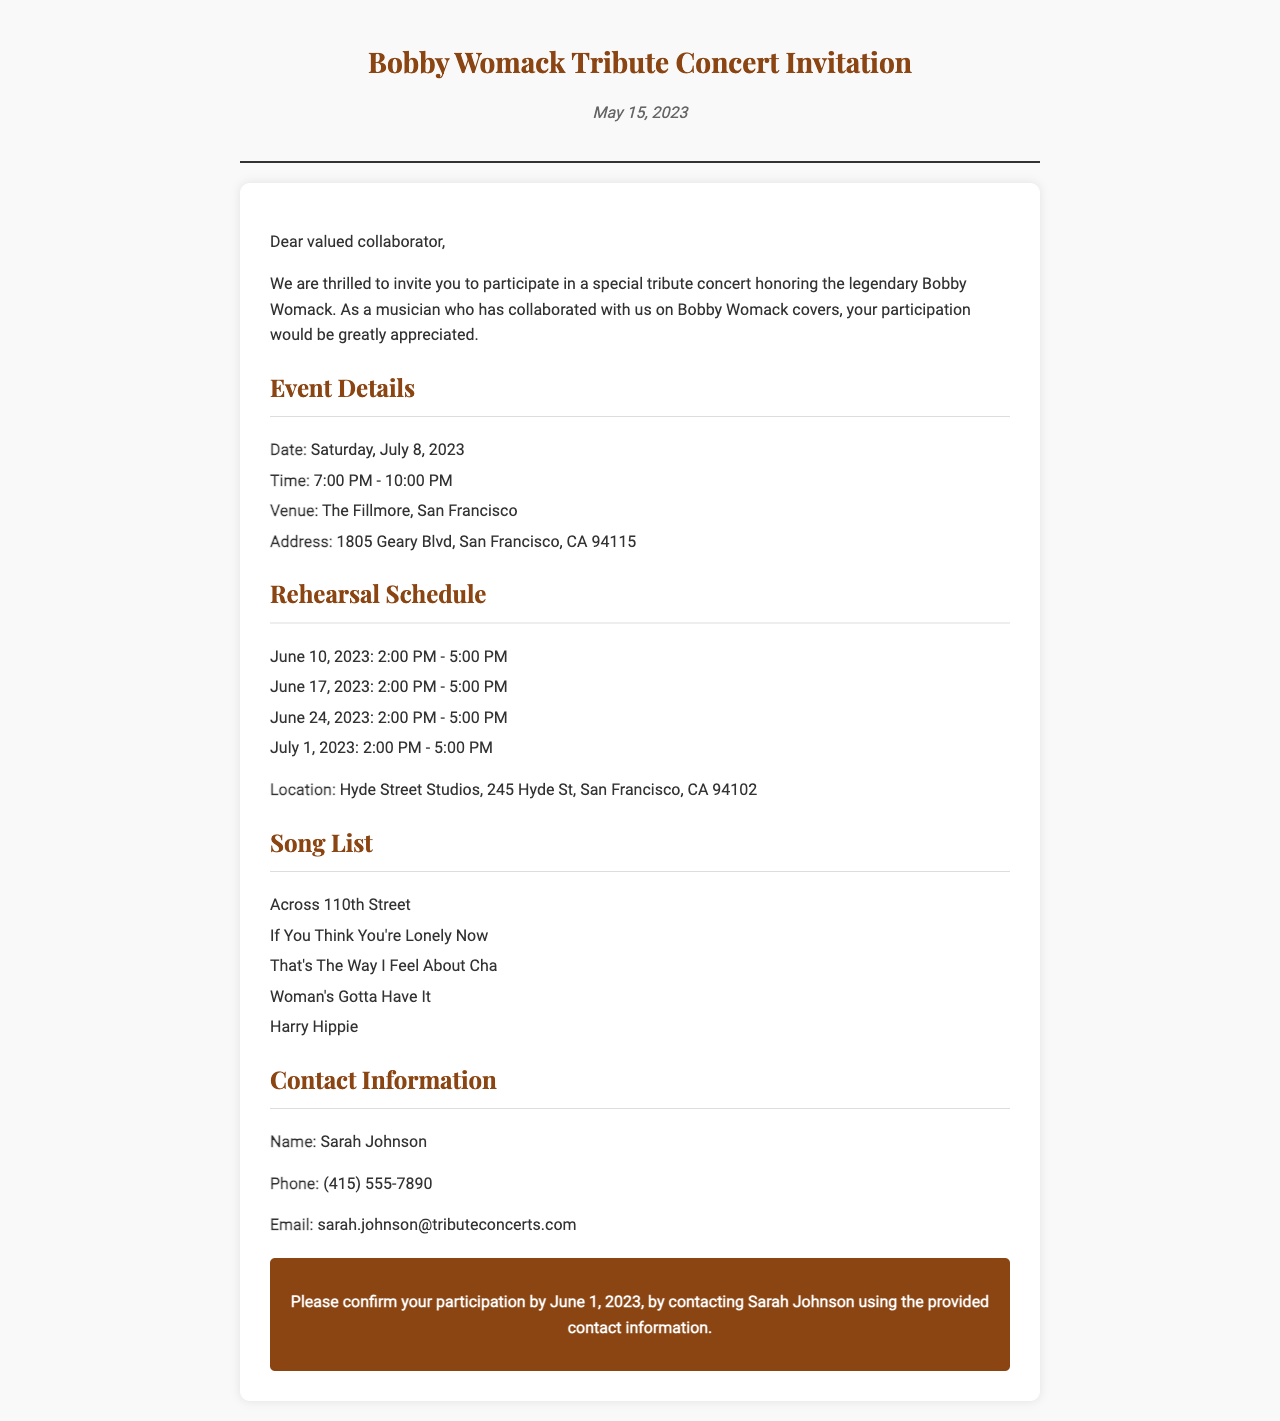What is the date of the concert? The concert is scheduled for July 8, 2023, as stated in the event details.
Answer: July 8, 2023 What is the venue for the tribute concert? The venue listed for the concert is The Fillmore, as mentioned in the event details.
Answer: The Fillmore What time does the concert start? The concert starts at 7:00 PM according to the event details.
Answer: 7:00 PM How many rehearsals are scheduled before the concert? There are four rehearsals listed before the concert, as shown in the rehearsal schedule.
Answer: Four Who should be contacted to confirm participation? Sarah Johnson is the person to contact, as mentioned in the contact information section.
Answer: Sarah Johnson What is the address of the rehearsal location? The address for the rehearsal location is provided in the rehearsal schedule.
Answer: 245 Hyde St, San Francisco, CA 94102 What is the RSVP deadline? The RSVP deadline is mentioned in the RSVP section of the document.
Answer: June 1, 2023 Which song from the list is about a woman's need? "Woman's Gotta Have It" addresses a woman's need, as listed in the song list.
Answer: Woman's Gotta Have It What is the phone number to contact for participation? The phone number to confirm participation is provided in the contact information section.
Answer: (415) 555-7890 